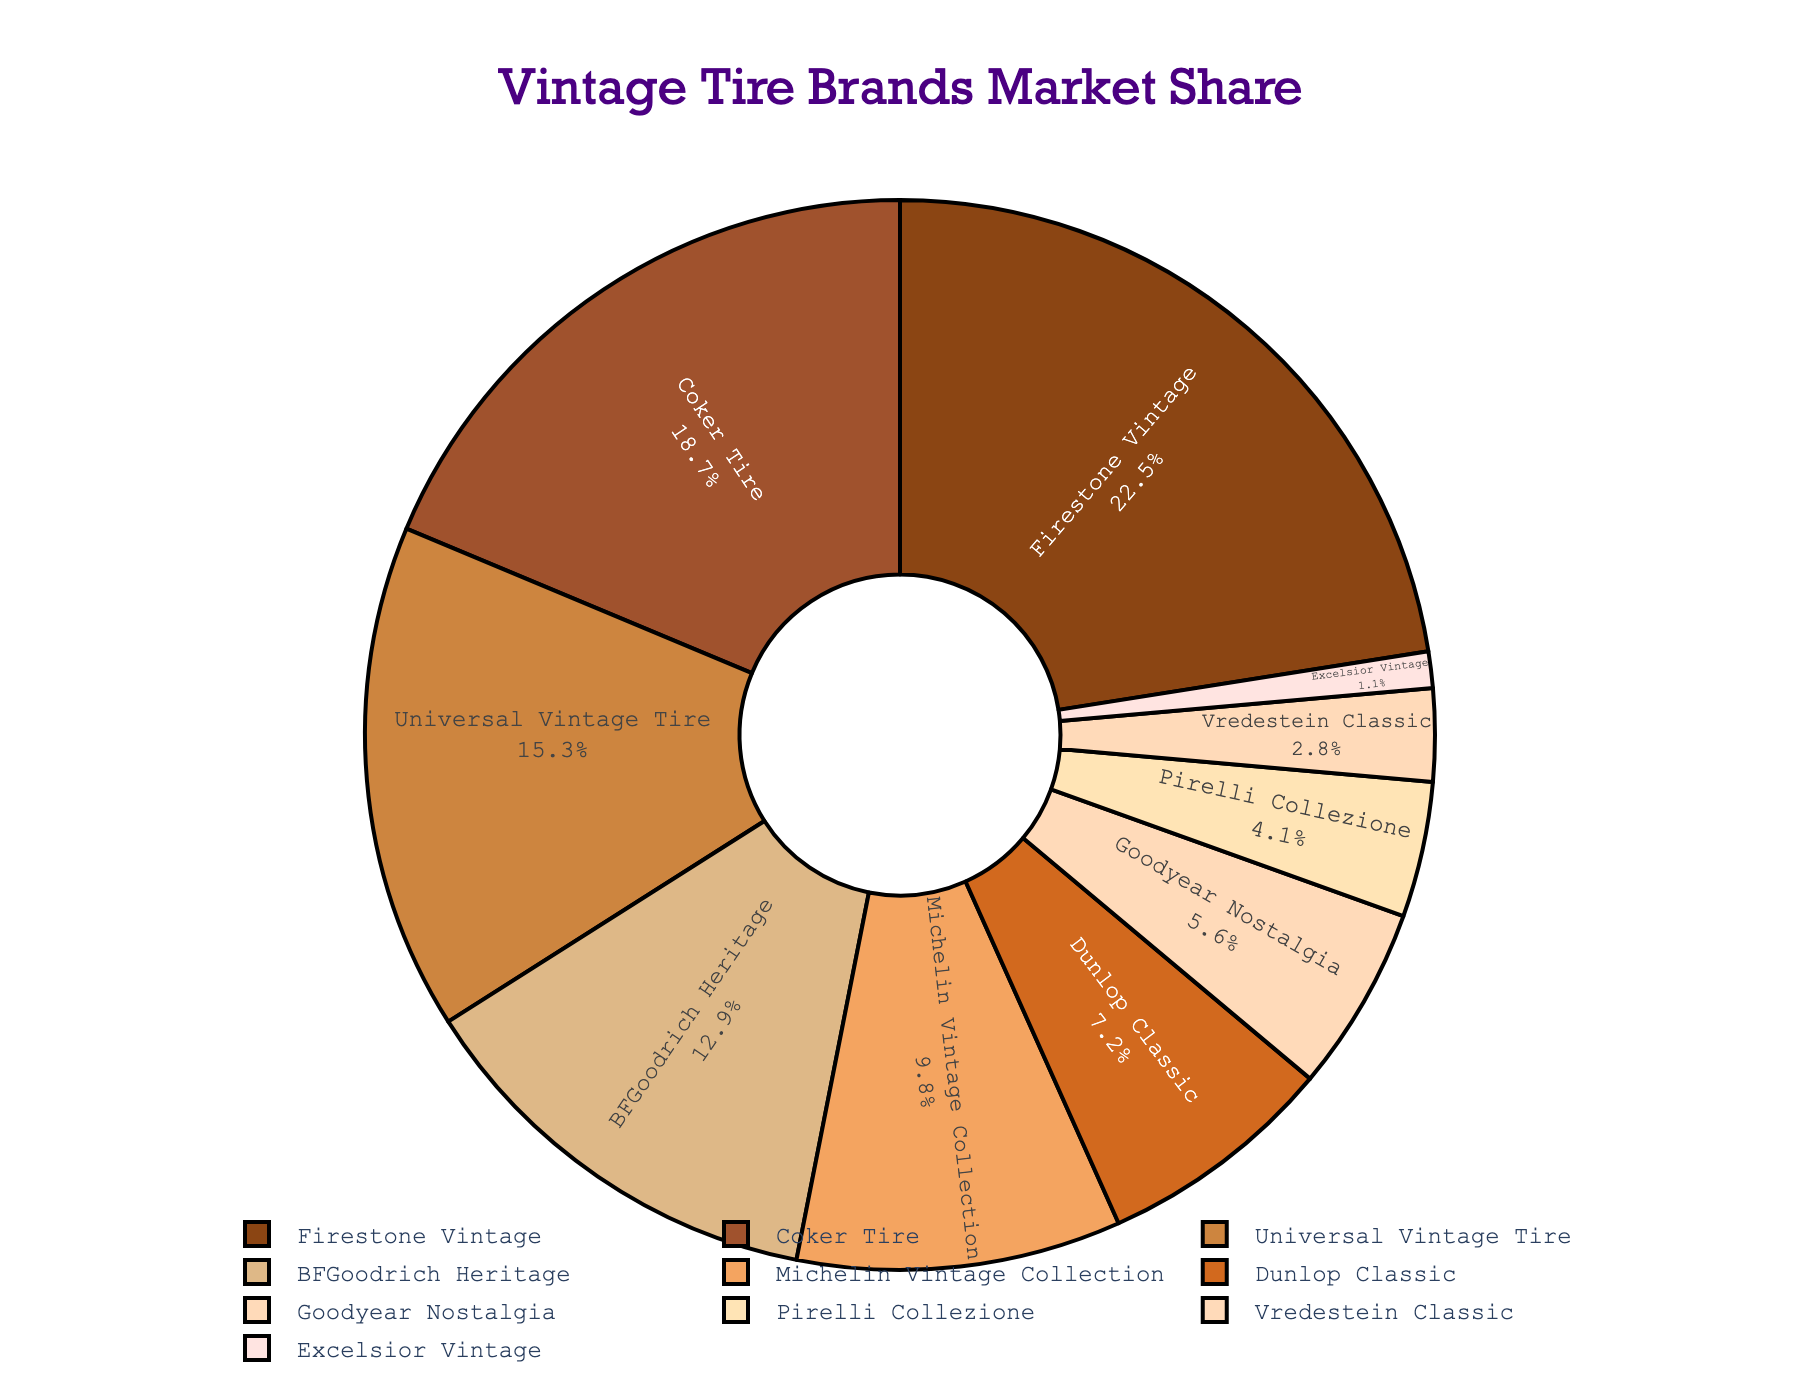Which vintage tire brand has the largest market share? By observing the pie chart, the segment with the largest area is labeled "Firestone Vintage" with a market share. You can see that it is more substantial compared to the others.
Answer: Firestone Vintage What is the combined market share of BFGoodrich Heritage and Michelin Vintage Collection? The market share of BFGoodrich Heritage is 12.9%, and that of Michelin Vintage Collection is 9.8%. Adding these two values together: 12.9 + 9.8 = 22.7%
Answer: 22.7% How much larger is the market share of Firestone Vintage compared to Universal Vintage Tire? Firestone Vintage has a market share of 22.5%, while Universal Vintage Tire has 15.3%. Subtracting these gives: 22.5 - 15.3 = 7.2%
Answer: 7.2% Which brand has the smallest market share and what is its value? By looking at the smallest segment of the pie chart, it’s labeled "Excelsior Vintage" with a market share. This shows it has the smallest market share compared to others.
Answer: Excelsior Vintage (1.1%) Is Coker Tire's market share greater than twice the market share of Goodyear Nostalgia? First, find twice Goodyear Nostalgia’s market share: 2 * 5.6 = 11.2%. Coker Tire's market share is 18.7%, which is indeed greater than 11.2%.
Answer: Yes What is the total market share of brands with less than 10% share each? Brands with less than 10% are Michelin Vintage Collection (9.8%), Dunlop Classic (7.2%), Goodyear Nostalgia (5.6%), Pirelli Collezione (4.1%), Vredestein Classic (2.8%), and Excelsior Vintage (1.1%). Adding these together: 9.8 + 7.2 + 5.6 + 4.1 + 2.8 + 1.1 = 30.6%
Answer: 30.6% How does the market share of Coker Tire compare to that of Vredestein Classic? Coker Tire has a market share of 18.7%, while Vredestein Classic has 2.8%. Calculating the difference: 18.7 - 2.8 = 15.9%. This shows Coker Tire has a significantly larger market share.
Answer: 15.9% Which brands have a market share between 5% and 10%? By examining the pie chart visually, the segments labeled "Michelin Vintage Collection" and "Dunlop Classic" fall within this range. Both have market shares between 5% and 10%.
Answer: Michelin Vintage Collection and Dunlop Classic What is the approximate market share difference between the top three brands combined and the rest combined? The top three brands are Firestone Vintage (22.5%), Coker Tire (18.7%), and Universal Vintage Tire (15.3%). Adding these: 22.5 + 18.7 + 15.3 = 56.5%. For the rest combined: 100 - 56.5 = 43.5%. The difference is: 56.5 - 43.5 = 13%.
Answer: 13% What percentage of the market is held by brands other than Firestone Vintage, Coker Tire, and Universal Vintage Tire? Summing the shares of Firestone Vintage (22.5%), Coker Tire (18.7%), and Universal Vintage Tire (15.3%) gives: 22.5 + 18.7 + 15.3 = 56.5%. Brands other than these three hold: 100 - 56.5 = 43.5% of the market.
Answer: 43.5% 